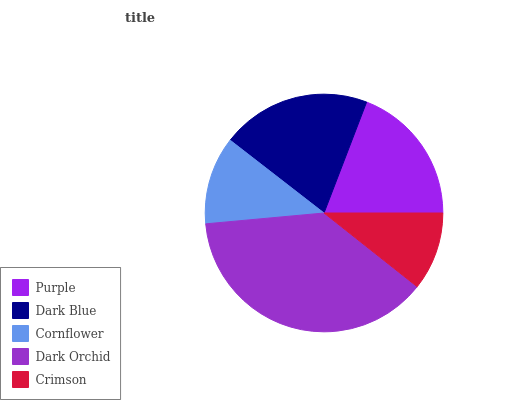Is Crimson the minimum?
Answer yes or no. Yes. Is Dark Orchid the maximum?
Answer yes or no. Yes. Is Dark Blue the minimum?
Answer yes or no. No. Is Dark Blue the maximum?
Answer yes or no. No. Is Dark Blue greater than Purple?
Answer yes or no. Yes. Is Purple less than Dark Blue?
Answer yes or no. Yes. Is Purple greater than Dark Blue?
Answer yes or no. No. Is Dark Blue less than Purple?
Answer yes or no. No. Is Purple the high median?
Answer yes or no. Yes. Is Purple the low median?
Answer yes or no. Yes. Is Cornflower the high median?
Answer yes or no. No. Is Crimson the low median?
Answer yes or no. No. 